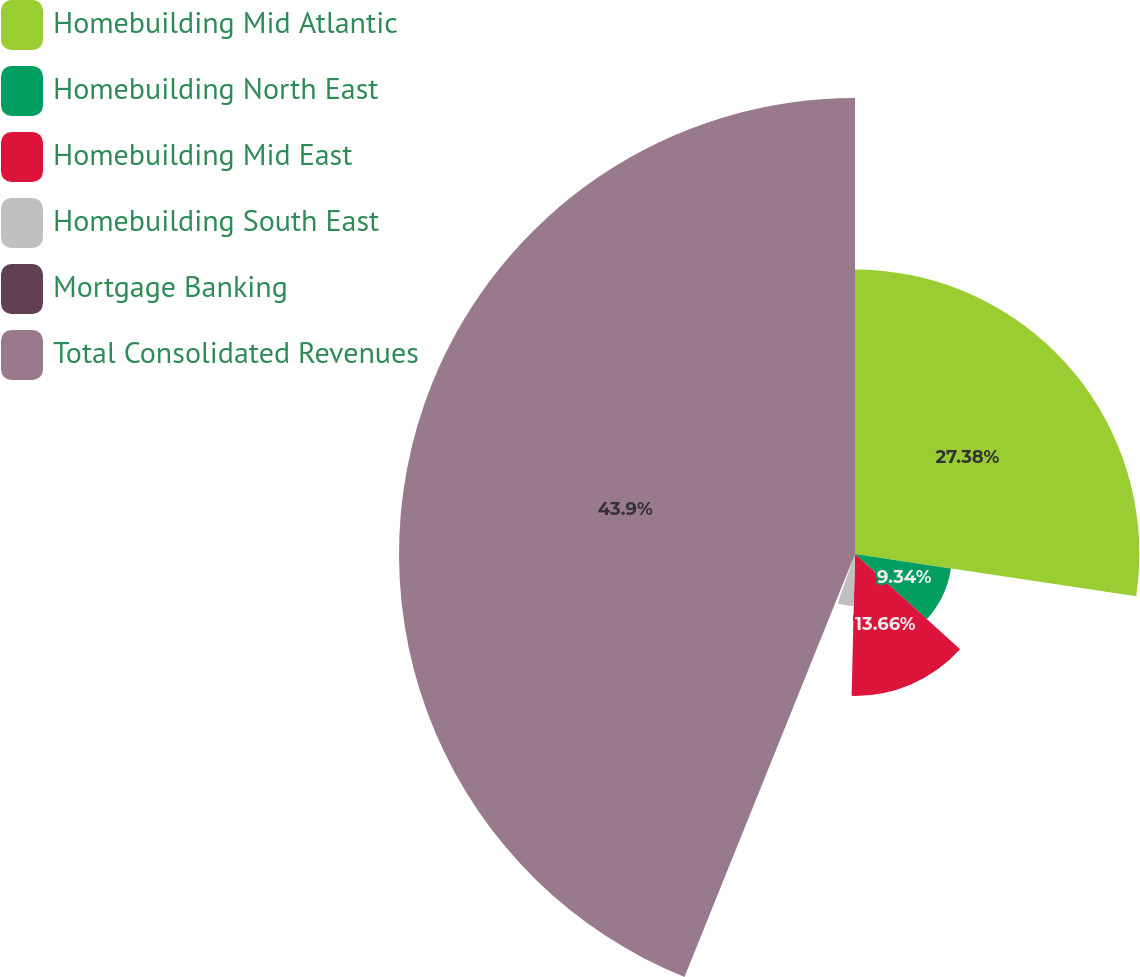Convert chart. <chart><loc_0><loc_0><loc_500><loc_500><pie_chart><fcel>Homebuilding Mid Atlantic<fcel>Homebuilding North East<fcel>Homebuilding Mid East<fcel>Homebuilding South East<fcel>Mortgage Banking<fcel>Total Consolidated Revenues<nl><fcel>27.38%<fcel>9.34%<fcel>13.66%<fcel>5.02%<fcel>0.7%<fcel>43.9%<nl></chart> 